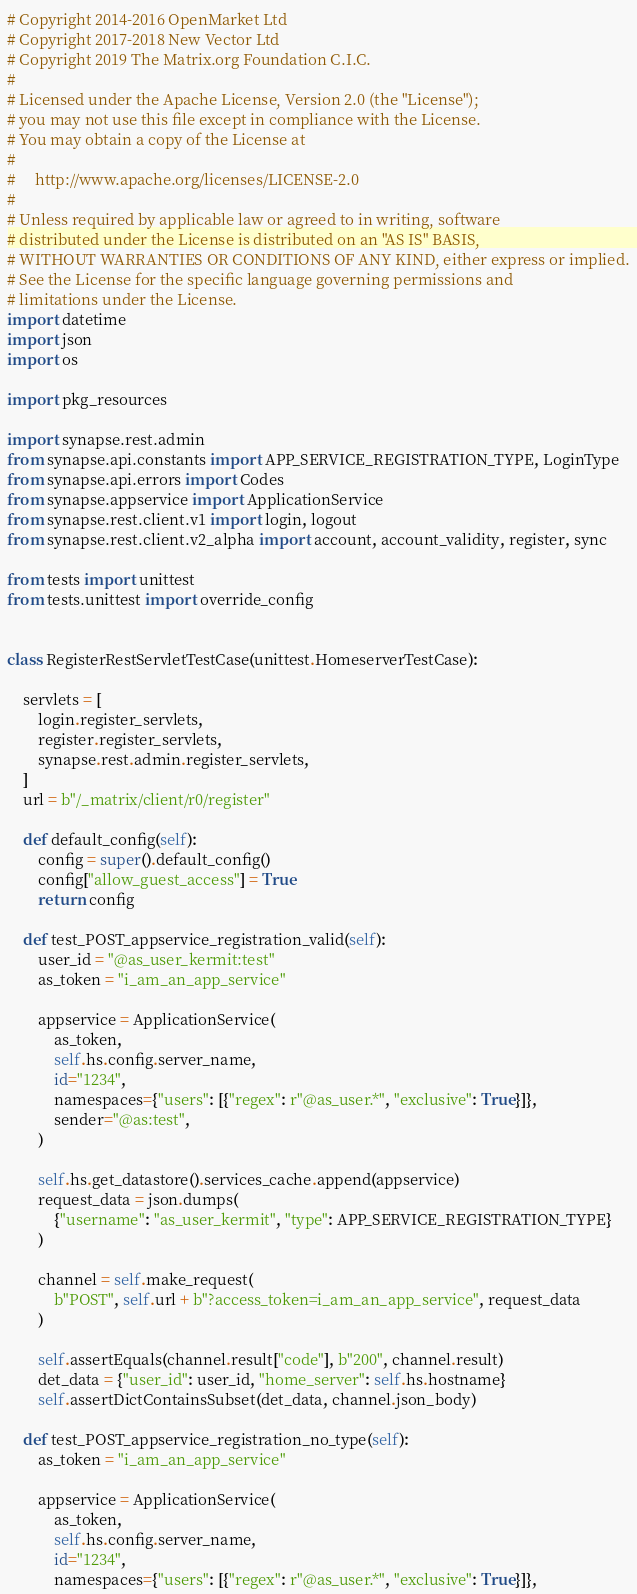Convert code to text. <code><loc_0><loc_0><loc_500><loc_500><_Python_># Copyright 2014-2016 OpenMarket Ltd
# Copyright 2017-2018 New Vector Ltd
# Copyright 2019 The Matrix.org Foundation C.I.C.
#
# Licensed under the Apache License, Version 2.0 (the "License");
# you may not use this file except in compliance with the License.
# You may obtain a copy of the License at
#
#     http://www.apache.org/licenses/LICENSE-2.0
#
# Unless required by applicable law or agreed to in writing, software
# distributed under the License is distributed on an "AS IS" BASIS,
# WITHOUT WARRANTIES OR CONDITIONS OF ANY KIND, either express or implied.
# See the License for the specific language governing permissions and
# limitations under the License.
import datetime
import json
import os

import pkg_resources

import synapse.rest.admin
from synapse.api.constants import APP_SERVICE_REGISTRATION_TYPE, LoginType
from synapse.api.errors import Codes
from synapse.appservice import ApplicationService
from synapse.rest.client.v1 import login, logout
from synapse.rest.client.v2_alpha import account, account_validity, register, sync

from tests import unittest
from tests.unittest import override_config


class RegisterRestServletTestCase(unittest.HomeserverTestCase):

    servlets = [
        login.register_servlets,
        register.register_servlets,
        synapse.rest.admin.register_servlets,
    ]
    url = b"/_matrix/client/r0/register"

    def default_config(self):
        config = super().default_config()
        config["allow_guest_access"] = True
        return config

    def test_POST_appservice_registration_valid(self):
        user_id = "@as_user_kermit:test"
        as_token = "i_am_an_app_service"

        appservice = ApplicationService(
            as_token,
            self.hs.config.server_name,
            id="1234",
            namespaces={"users": [{"regex": r"@as_user.*", "exclusive": True}]},
            sender="@as:test",
        )

        self.hs.get_datastore().services_cache.append(appservice)
        request_data = json.dumps(
            {"username": "as_user_kermit", "type": APP_SERVICE_REGISTRATION_TYPE}
        )

        channel = self.make_request(
            b"POST", self.url + b"?access_token=i_am_an_app_service", request_data
        )

        self.assertEquals(channel.result["code"], b"200", channel.result)
        det_data = {"user_id": user_id, "home_server": self.hs.hostname}
        self.assertDictContainsSubset(det_data, channel.json_body)

    def test_POST_appservice_registration_no_type(self):
        as_token = "i_am_an_app_service"

        appservice = ApplicationService(
            as_token,
            self.hs.config.server_name,
            id="1234",
            namespaces={"users": [{"regex": r"@as_user.*", "exclusive": True}]},</code> 